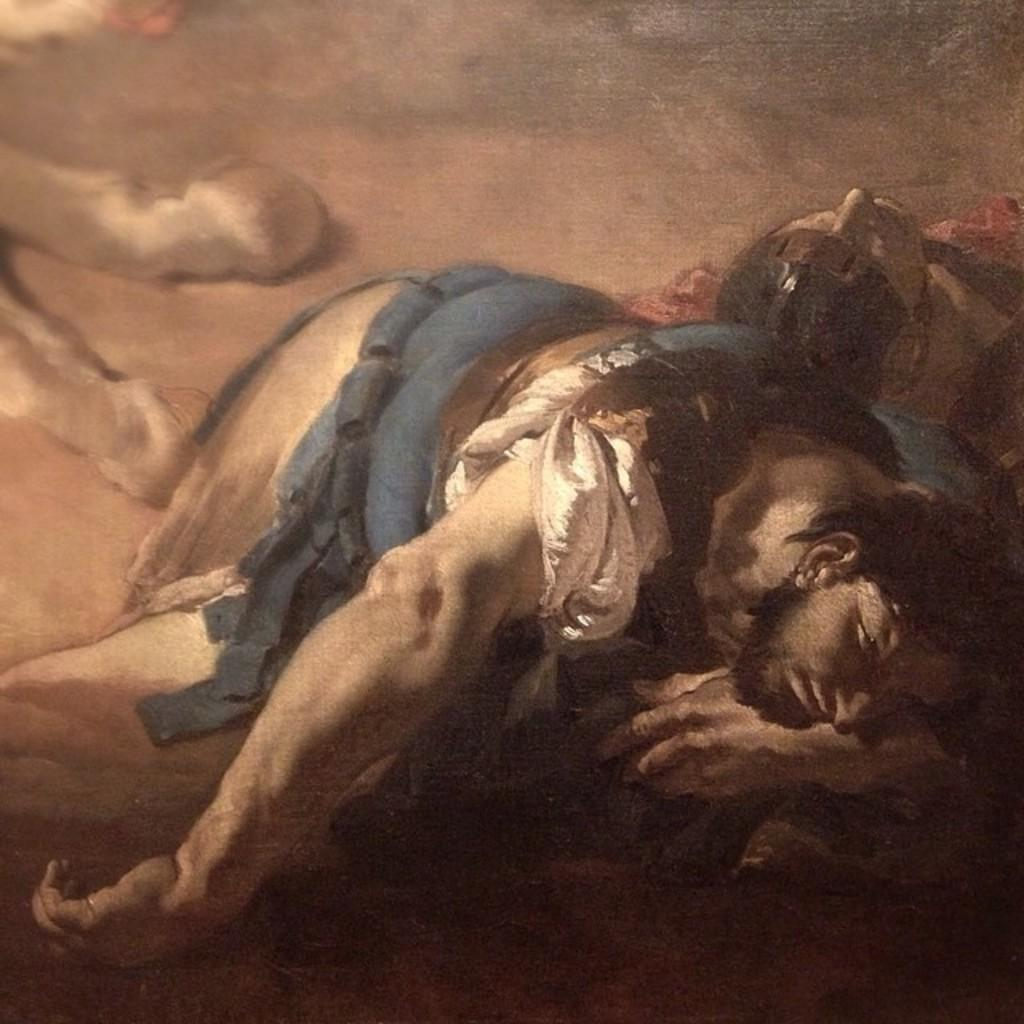What are the two people in the image doing? The two people in the image are lying on the ground. Can you describe the position of the animal's leg in the image? The leg of an animal is visible in the image. What type of lead is the person holding in the image? There is no lead present in the image. What color is the lipstick on the person's lips in the image? There is no person with lipstick in the image; only two people lying on the ground and an animal's leg are visible. 